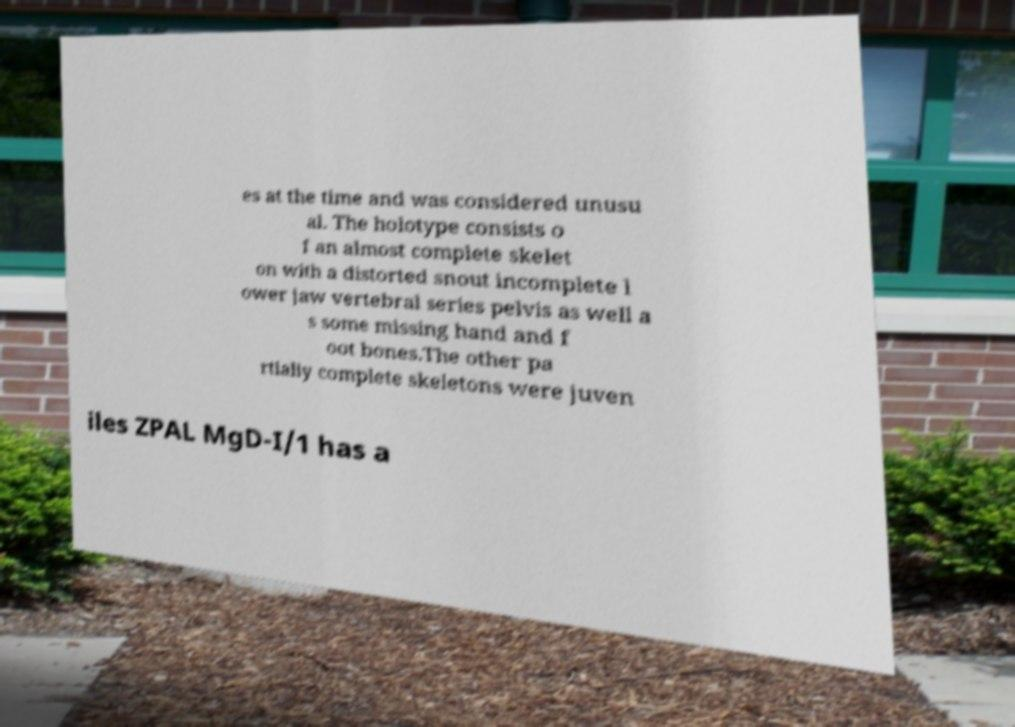Please read and relay the text visible in this image. What does it say? es at the time and was considered unusu al. The holotype consists o f an almost complete skelet on with a distorted snout incomplete l ower jaw vertebral series pelvis as well a s some missing hand and f oot bones.The other pa rtially complete skeletons were juven iles ZPAL MgD-I/1 has a 